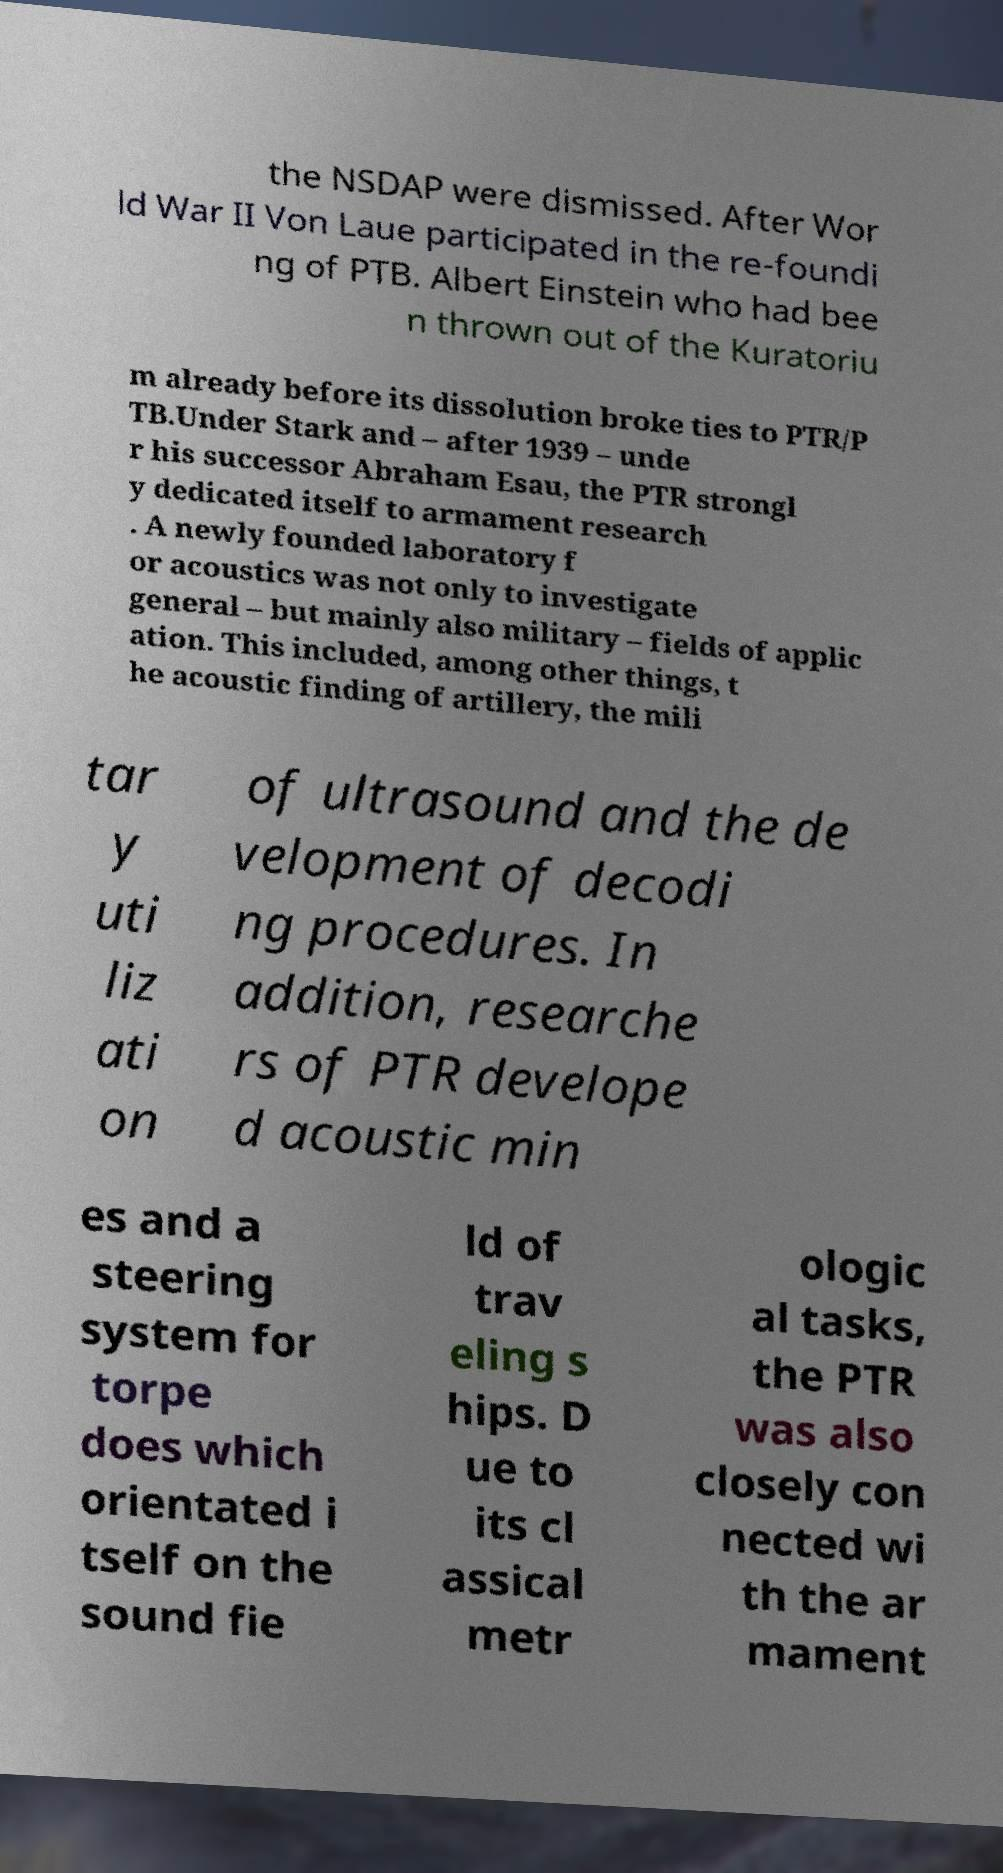Please identify and transcribe the text found in this image. the NSDAP were dismissed. After Wor ld War II Von Laue participated in the re-foundi ng of PTB. Albert Einstein who had bee n thrown out of the Kuratoriu m already before its dissolution broke ties to PTR/P TB.Under Stark and – after 1939 – unde r his successor Abraham Esau, the PTR strongl y dedicated itself to armament research . A newly founded laboratory f or acoustics was not only to investigate general – but mainly also military – fields of applic ation. This included, among other things, t he acoustic finding of artillery, the mili tar y uti liz ati on of ultrasound and the de velopment of decodi ng procedures. In addition, researche rs of PTR develope d acoustic min es and a steering system for torpe does which orientated i tself on the sound fie ld of trav eling s hips. D ue to its cl assical metr ologic al tasks, the PTR was also closely con nected wi th the ar mament 